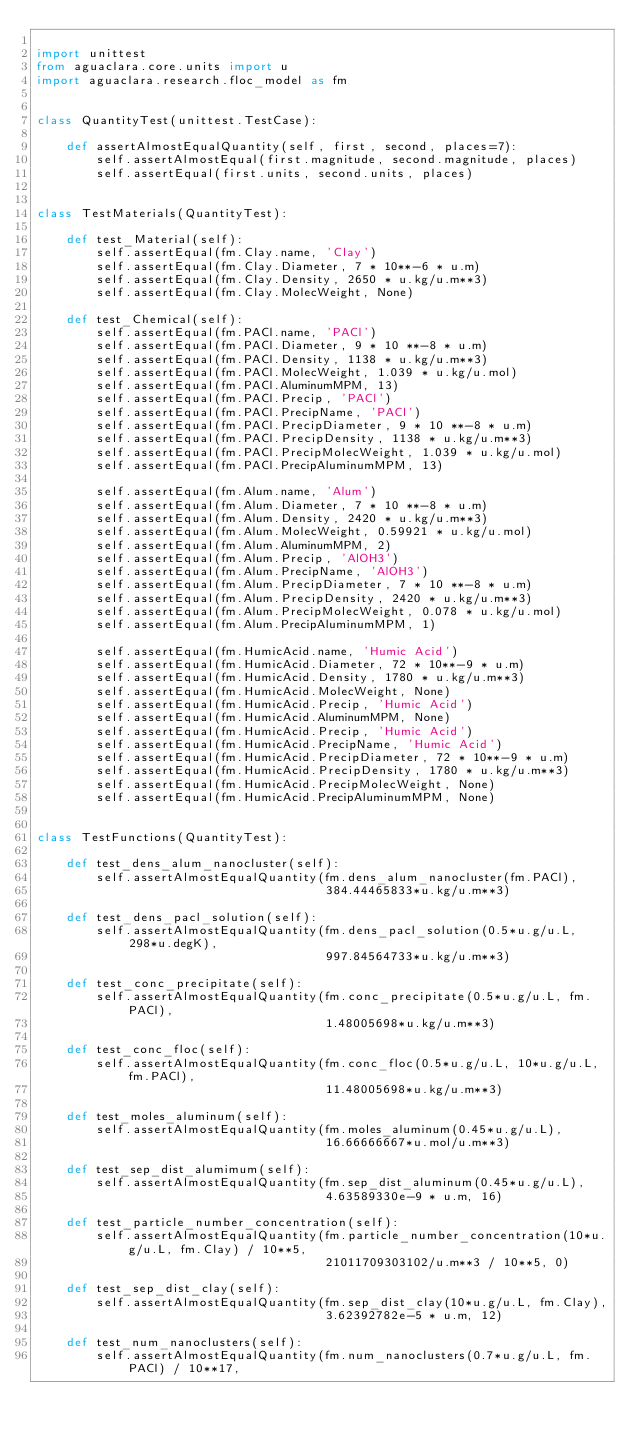<code> <loc_0><loc_0><loc_500><loc_500><_Python_>
import unittest
from aguaclara.core.units import u
import aguaclara.research.floc_model as fm


class QuantityTest(unittest.TestCase):

    def assertAlmostEqualQuantity(self, first, second, places=7):
        self.assertAlmostEqual(first.magnitude, second.magnitude, places)
        self.assertEqual(first.units, second.units, places)


class TestMaterials(QuantityTest):

    def test_Material(self):
        self.assertEqual(fm.Clay.name, 'Clay')
        self.assertEqual(fm.Clay.Diameter, 7 * 10**-6 * u.m)
        self.assertEqual(fm.Clay.Density, 2650 * u.kg/u.m**3)
        self.assertEqual(fm.Clay.MolecWeight, None)

    def test_Chemical(self):
        self.assertEqual(fm.PACl.name, 'PACl')
        self.assertEqual(fm.PACl.Diameter, 9 * 10 **-8 * u.m)
        self.assertEqual(fm.PACl.Density, 1138 * u.kg/u.m**3)
        self.assertEqual(fm.PACl.MolecWeight, 1.039 * u.kg/u.mol)
        self.assertEqual(fm.PACl.AluminumMPM, 13)
        self.assertEqual(fm.PACl.Precip, 'PACl')
        self.assertEqual(fm.PACl.PrecipName, 'PACl')
        self.assertEqual(fm.PACl.PrecipDiameter, 9 * 10 **-8 * u.m)
        self.assertEqual(fm.PACl.PrecipDensity, 1138 * u.kg/u.m**3)
        self.assertEqual(fm.PACl.PrecipMolecWeight, 1.039 * u.kg/u.mol)
        self.assertEqual(fm.PACl.PrecipAluminumMPM, 13)

        self.assertEqual(fm.Alum.name, 'Alum')
        self.assertEqual(fm.Alum.Diameter, 7 * 10 **-8 * u.m)
        self.assertEqual(fm.Alum.Density, 2420 * u.kg/u.m**3)
        self.assertEqual(fm.Alum.MolecWeight, 0.59921 * u.kg/u.mol)
        self.assertEqual(fm.Alum.AluminumMPM, 2)
        self.assertEqual(fm.Alum.Precip, 'AlOH3')
        self.assertEqual(fm.Alum.PrecipName, 'AlOH3')
        self.assertEqual(fm.Alum.PrecipDiameter, 7 * 10 **-8 * u.m)
        self.assertEqual(fm.Alum.PrecipDensity, 2420 * u.kg/u.m**3)
        self.assertEqual(fm.Alum.PrecipMolecWeight, 0.078 * u.kg/u.mol)
        self.assertEqual(fm.Alum.PrecipAluminumMPM, 1)

        self.assertEqual(fm.HumicAcid.name, 'Humic Acid')
        self.assertEqual(fm.HumicAcid.Diameter, 72 * 10**-9 * u.m)
        self.assertEqual(fm.HumicAcid.Density, 1780 * u.kg/u.m**3)
        self.assertEqual(fm.HumicAcid.MolecWeight, None)
        self.assertEqual(fm.HumicAcid.Precip, 'Humic Acid')
        self.assertEqual(fm.HumicAcid.AluminumMPM, None)
        self.assertEqual(fm.HumicAcid.Precip, 'Humic Acid')
        self.assertEqual(fm.HumicAcid.PrecipName, 'Humic Acid')
        self.assertEqual(fm.HumicAcid.PrecipDiameter, 72 * 10**-9 * u.m)
        self.assertEqual(fm.HumicAcid.PrecipDensity, 1780 * u.kg/u.m**3)
        self.assertEqual(fm.HumicAcid.PrecipMolecWeight, None)
        self.assertEqual(fm.HumicAcid.PrecipAluminumMPM, None)


class TestFunctions(QuantityTest):

    def test_dens_alum_nanocluster(self):
        self.assertAlmostEqualQuantity(fm.dens_alum_nanocluster(fm.PACl),
                                       384.44465833*u.kg/u.m**3)

    def test_dens_pacl_solution(self):
        self.assertAlmostEqualQuantity(fm.dens_pacl_solution(0.5*u.g/u.L, 298*u.degK),
                                       997.84564733*u.kg/u.m**3)

    def test_conc_precipitate(self):
        self.assertAlmostEqualQuantity(fm.conc_precipitate(0.5*u.g/u.L, fm.PACl),
                                       1.48005698*u.kg/u.m**3)

    def test_conc_floc(self):
        self.assertAlmostEqualQuantity(fm.conc_floc(0.5*u.g/u.L, 10*u.g/u.L, fm.PACl),
                                       11.48005698*u.kg/u.m**3)

    def test_moles_aluminum(self):
        self.assertAlmostEqualQuantity(fm.moles_aluminum(0.45*u.g/u.L),
                                       16.66666667*u.mol/u.m**3)

    def test_sep_dist_alumimum(self):
        self.assertAlmostEqualQuantity(fm.sep_dist_aluminum(0.45*u.g/u.L),
                                       4.63589330e-9 * u.m, 16)

    def test_particle_number_concentration(self):
        self.assertAlmostEqualQuantity(fm.particle_number_concentration(10*u.g/u.L, fm.Clay) / 10**5,
                                       21011709303102/u.m**3 / 10**5, 0)

    def test_sep_dist_clay(self):
        self.assertAlmostEqualQuantity(fm.sep_dist_clay(10*u.g/u.L, fm.Clay),
                                       3.62392782e-5 * u.m, 12)

    def test_num_nanoclusters(self):
        self.assertAlmostEqualQuantity(fm.num_nanoclusters(0.7*u.g/u.L, fm.PACl) / 10**17,</code> 